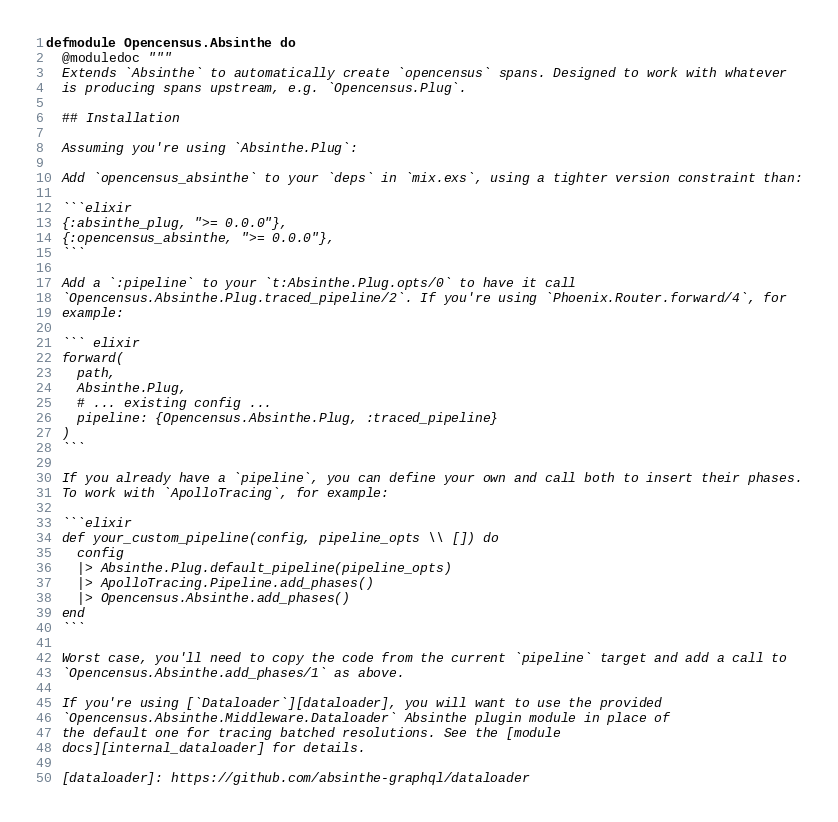Convert code to text. <code><loc_0><loc_0><loc_500><loc_500><_Elixir_>defmodule Opencensus.Absinthe do
  @moduledoc """
  Extends `Absinthe` to automatically create `opencensus` spans. Designed to work with whatever
  is producing spans upstream, e.g. `Opencensus.Plug`.

  ## Installation

  Assuming you're using `Absinthe.Plug`:

  Add `opencensus_absinthe` to your `deps` in `mix.exs`, using a tighter version constraint than:

  ```elixir
  {:absinthe_plug, ">= 0.0.0"},
  {:opencensus_absinthe, ">= 0.0.0"},
  ```

  Add a `:pipeline` to your `t:Absinthe.Plug.opts/0` to have it call
  `Opencensus.Absinthe.Plug.traced_pipeline/2`. If you're using `Phoenix.Router.forward/4`, for
  example:

  ``` elixir
  forward(
    path,
    Absinthe.Plug,
    # ... existing config ...
    pipeline: {Opencensus.Absinthe.Plug, :traced_pipeline}
  )
  ```

  If you already have a `pipeline`, you can define your own and call both to insert their phases.
  To work with `ApolloTracing`, for example:

  ```elixir
  def your_custom_pipeline(config, pipeline_opts \\ []) do
    config
    |> Absinthe.Plug.default_pipeline(pipeline_opts)
    |> ApolloTracing.Pipeline.add_phases()
    |> Opencensus.Absinthe.add_phases()
  end
  ```

  Worst case, you'll need to copy the code from the current `pipeline` target and add a call to
  `Opencensus.Absinthe.add_phases/1` as above.

  If you're using [`Dataloader`][dataloader], you will want to use the provided
  `Opencensus.Absinthe.Middleware.Dataloader` Absinthe plugin module in place of
  the default one for tracing batched resolutions. See the [module
  docs][internal_dataloader] for details.

  [dataloader]: https://github.com/absinthe-graphql/dataloader</code> 